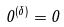<formula> <loc_0><loc_0><loc_500><loc_500>0 ^ { ( \delta ) } = 0</formula> 